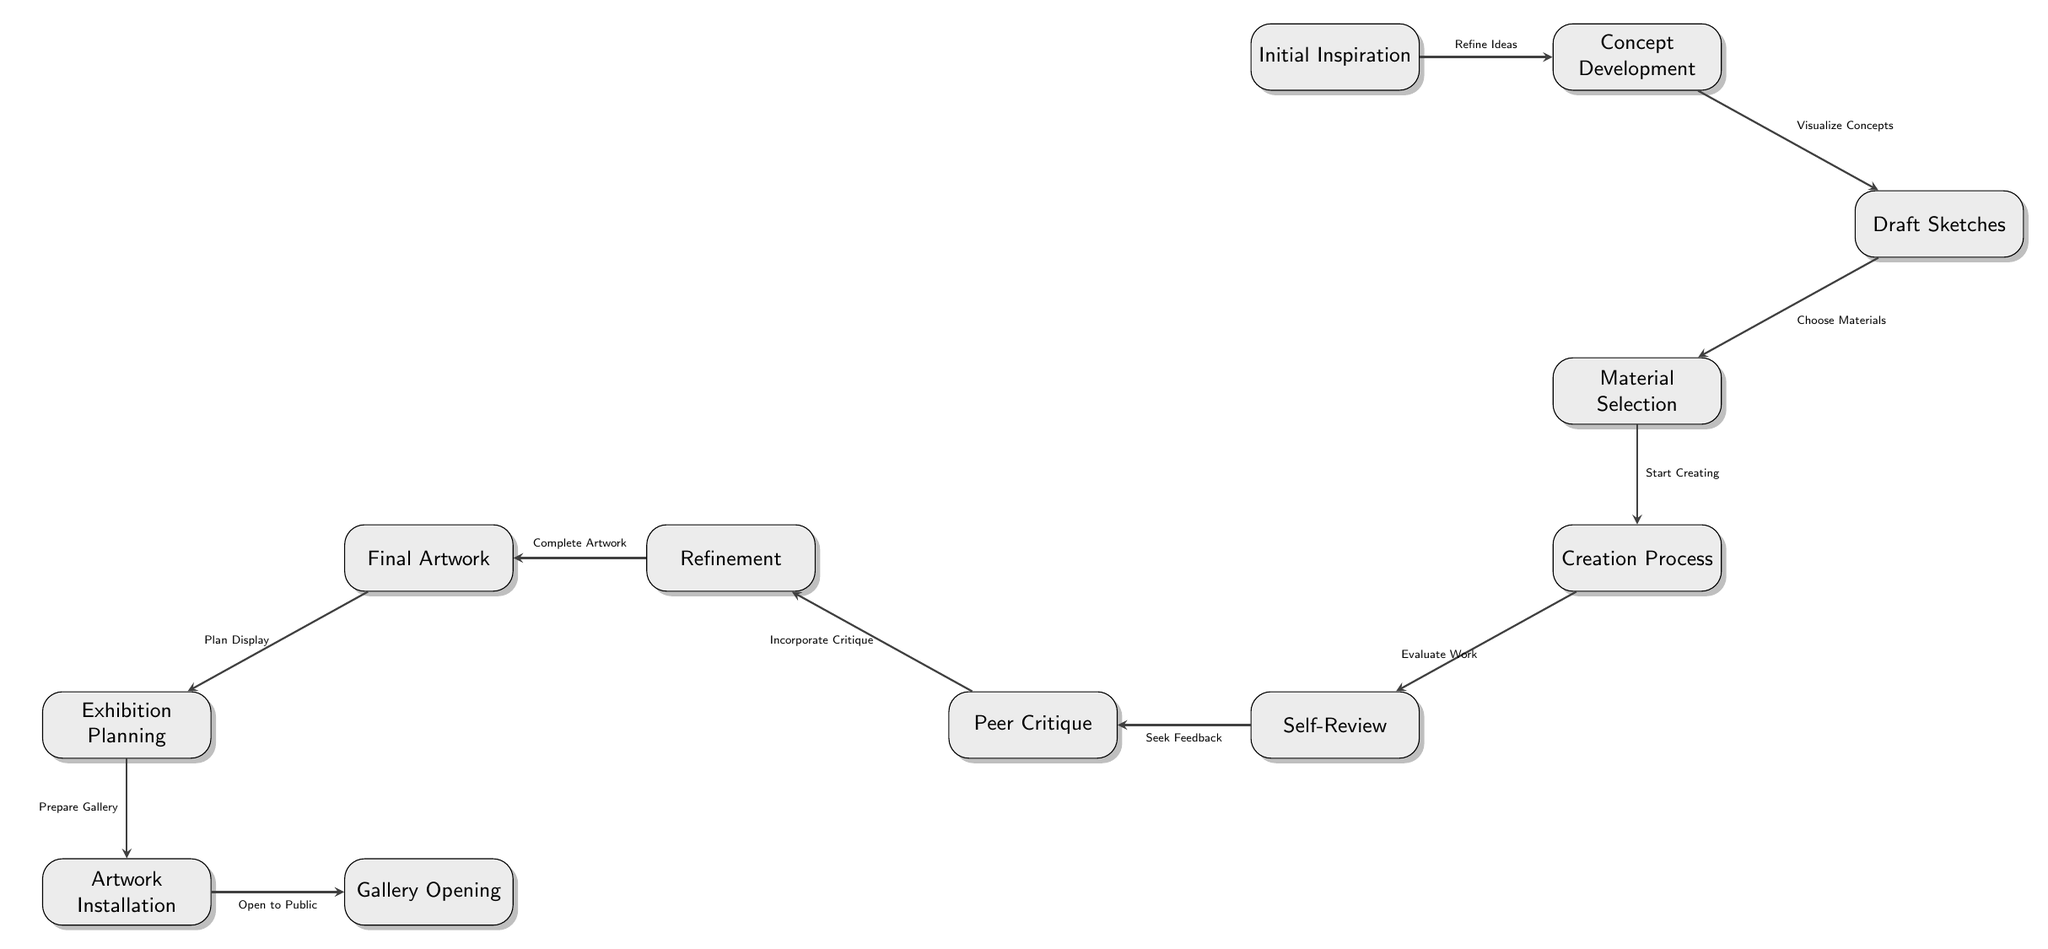What is the first step of the artwork journey? The first step of the artwork journey is labeled as "Initial Inspiration." This can be found at the top of the diagram as the starting node.
Answer: Initial Inspiration How many nodes are present in the diagram? By counting all the distinct labeled steps in the flowchart, we find there are a total of 12 nodes representing different stages of the artwork journey.
Answer: 12 What follows "Creation Process" in the flowchart? In the flowchart, "Creation Process" is followed by "Self-Review." This is indicated by the directed edge connecting these two nodes in the diagram.
Answer: Self-Review What is the last step before the gallery opening? The last step before the gallery opening is "Artwork Installation." This is the penultimate node in the diagram leading to the final node.
Answer: Artwork Installation How does "Peer Critique" relate to "Refinement"? "Peer Critique" leads to "Refinement." The directed edge shows that after seeking peer feedback, the next step is to refine the artwork based on that critique.
Answer: Incorporate Critique What is the main action associated with "Draft Sketches"? The action associated with "Draft Sketches" is to "Choose Materials." This connection is depicted with an arrow leading from "Draft Sketches" to the "Material Selection" node.
Answer: Choose Materials Which step involves seeking feedback on the artwork? The step involving seeking feedback is labeled "Peer Critique." This is where the artist would gather opinions and insights from fellow peers.
Answer: Peer Critique What is required after "Final Artwork"? After "Final Artwork," one must plan for its display according to the flowchart, represented by the node "Exhibition Planning."
Answer: Plan Display What step comes after "Material Selection"? The step that comes after "Material Selection" is "Creation Process," as indicated by the directed flow connecting these two stages in the artwork journey.
Answer: Creation Process 